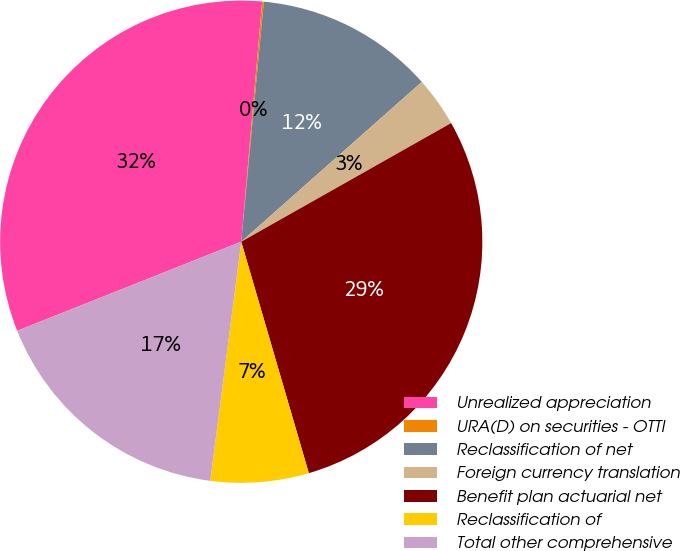Convert chart. <chart><loc_0><loc_0><loc_500><loc_500><pie_chart><fcel>Unrealized appreciation<fcel>URA(D) on securities - OTTI<fcel>Reclassification of net<fcel>Foreign currency translation<fcel>Benefit plan actuarial net<fcel>Reclassification of<fcel>Total other comprehensive<nl><fcel>32.41%<fcel>0.11%<fcel>11.98%<fcel>3.34%<fcel>28.67%<fcel>6.57%<fcel>16.93%<nl></chart> 